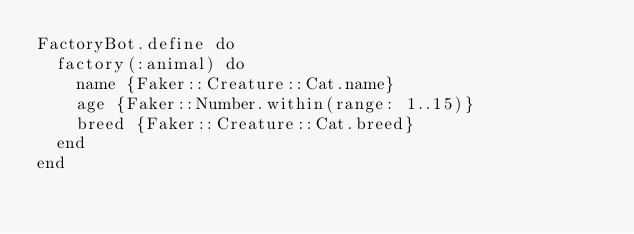Convert code to text. <code><loc_0><loc_0><loc_500><loc_500><_Ruby_>FactoryBot.define do
  factory(:animal) do
    name {Faker::Creature::Cat.name}
    age {Faker::Number.within(range: 1..15)}
    breed {Faker::Creature::Cat.breed}
  end
end</code> 